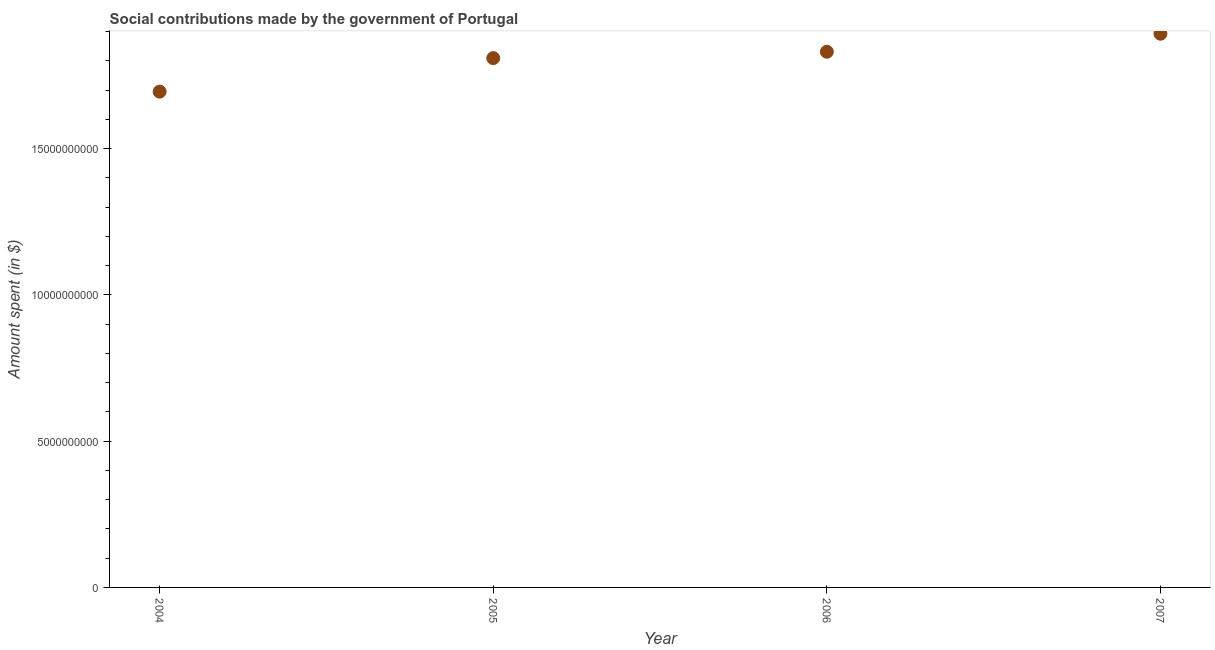What is the amount spent in making social contributions in 2004?
Make the answer very short. 1.69e+1. Across all years, what is the maximum amount spent in making social contributions?
Give a very brief answer. 1.89e+1. Across all years, what is the minimum amount spent in making social contributions?
Your response must be concise. 1.69e+1. In which year was the amount spent in making social contributions minimum?
Provide a succinct answer. 2004. What is the sum of the amount spent in making social contributions?
Keep it short and to the point. 7.23e+1. What is the difference between the amount spent in making social contributions in 2004 and 2006?
Offer a terse response. -1.36e+09. What is the average amount spent in making social contributions per year?
Give a very brief answer. 1.81e+1. What is the median amount spent in making social contributions?
Offer a terse response. 1.82e+1. Do a majority of the years between 2006 and 2007 (inclusive) have amount spent in making social contributions greater than 18000000000 $?
Provide a short and direct response. Yes. What is the ratio of the amount spent in making social contributions in 2006 to that in 2007?
Ensure brevity in your answer.  0.97. Is the amount spent in making social contributions in 2006 less than that in 2007?
Offer a terse response. Yes. Is the difference between the amount spent in making social contributions in 2004 and 2006 greater than the difference between any two years?
Your response must be concise. No. What is the difference between the highest and the second highest amount spent in making social contributions?
Your answer should be compact. 6.16e+08. Is the sum of the amount spent in making social contributions in 2006 and 2007 greater than the maximum amount spent in making social contributions across all years?
Provide a short and direct response. Yes. What is the difference between the highest and the lowest amount spent in making social contributions?
Offer a very short reply. 1.98e+09. In how many years, is the amount spent in making social contributions greater than the average amount spent in making social contributions taken over all years?
Provide a succinct answer. 3. Does the amount spent in making social contributions monotonically increase over the years?
Keep it short and to the point. Yes. Does the graph contain any zero values?
Give a very brief answer. No. Does the graph contain grids?
Your answer should be very brief. No. What is the title of the graph?
Offer a very short reply. Social contributions made by the government of Portugal. What is the label or title of the X-axis?
Your response must be concise. Year. What is the label or title of the Y-axis?
Provide a short and direct response. Amount spent (in $). What is the Amount spent (in $) in 2004?
Give a very brief answer. 1.69e+1. What is the Amount spent (in $) in 2005?
Keep it short and to the point. 1.81e+1. What is the Amount spent (in $) in 2006?
Your answer should be very brief. 1.83e+1. What is the Amount spent (in $) in 2007?
Keep it short and to the point. 1.89e+1. What is the difference between the Amount spent (in $) in 2004 and 2005?
Your response must be concise. -1.15e+09. What is the difference between the Amount spent (in $) in 2004 and 2006?
Offer a very short reply. -1.36e+09. What is the difference between the Amount spent (in $) in 2004 and 2007?
Your answer should be compact. -1.98e+09. What is the difference between the Amount spent (in $) in 2005 and 2006?
Your answer should be compact. -2.18e+08. What is the difference between the Amount spent (in $) in 2005 and 2007?
Provide a short and direct response. -8.34e+08. What is the difference between the Amount spent (in $) in 2006 and 2007?
Make the answer very short. -6.16e+08. What is the ratio of the Amount spent (in $) in 2004 to that in 2005?
Keep it short and to the point. 0.94. What is the ratio of the Amount spent (in $) in 2004 to that in 2006?
Make the answer very short. 0.93. What is the ratio of the Amount spent (in $) in 2004 to that in 2007?
Your response must be concise. 0.9. What is the ratio of the Amount spent (in $) in 2005 to that in 2006?
Offer a terse response. 0.99. What is the ratio of the Amount spent (in $) in 2005 to that in 2007?
Offer a terse response. 0.96. What is the ratio of the Amount spent (in $) in 2006 to that in 2007?
Provide a short and direct response. 0.97. 